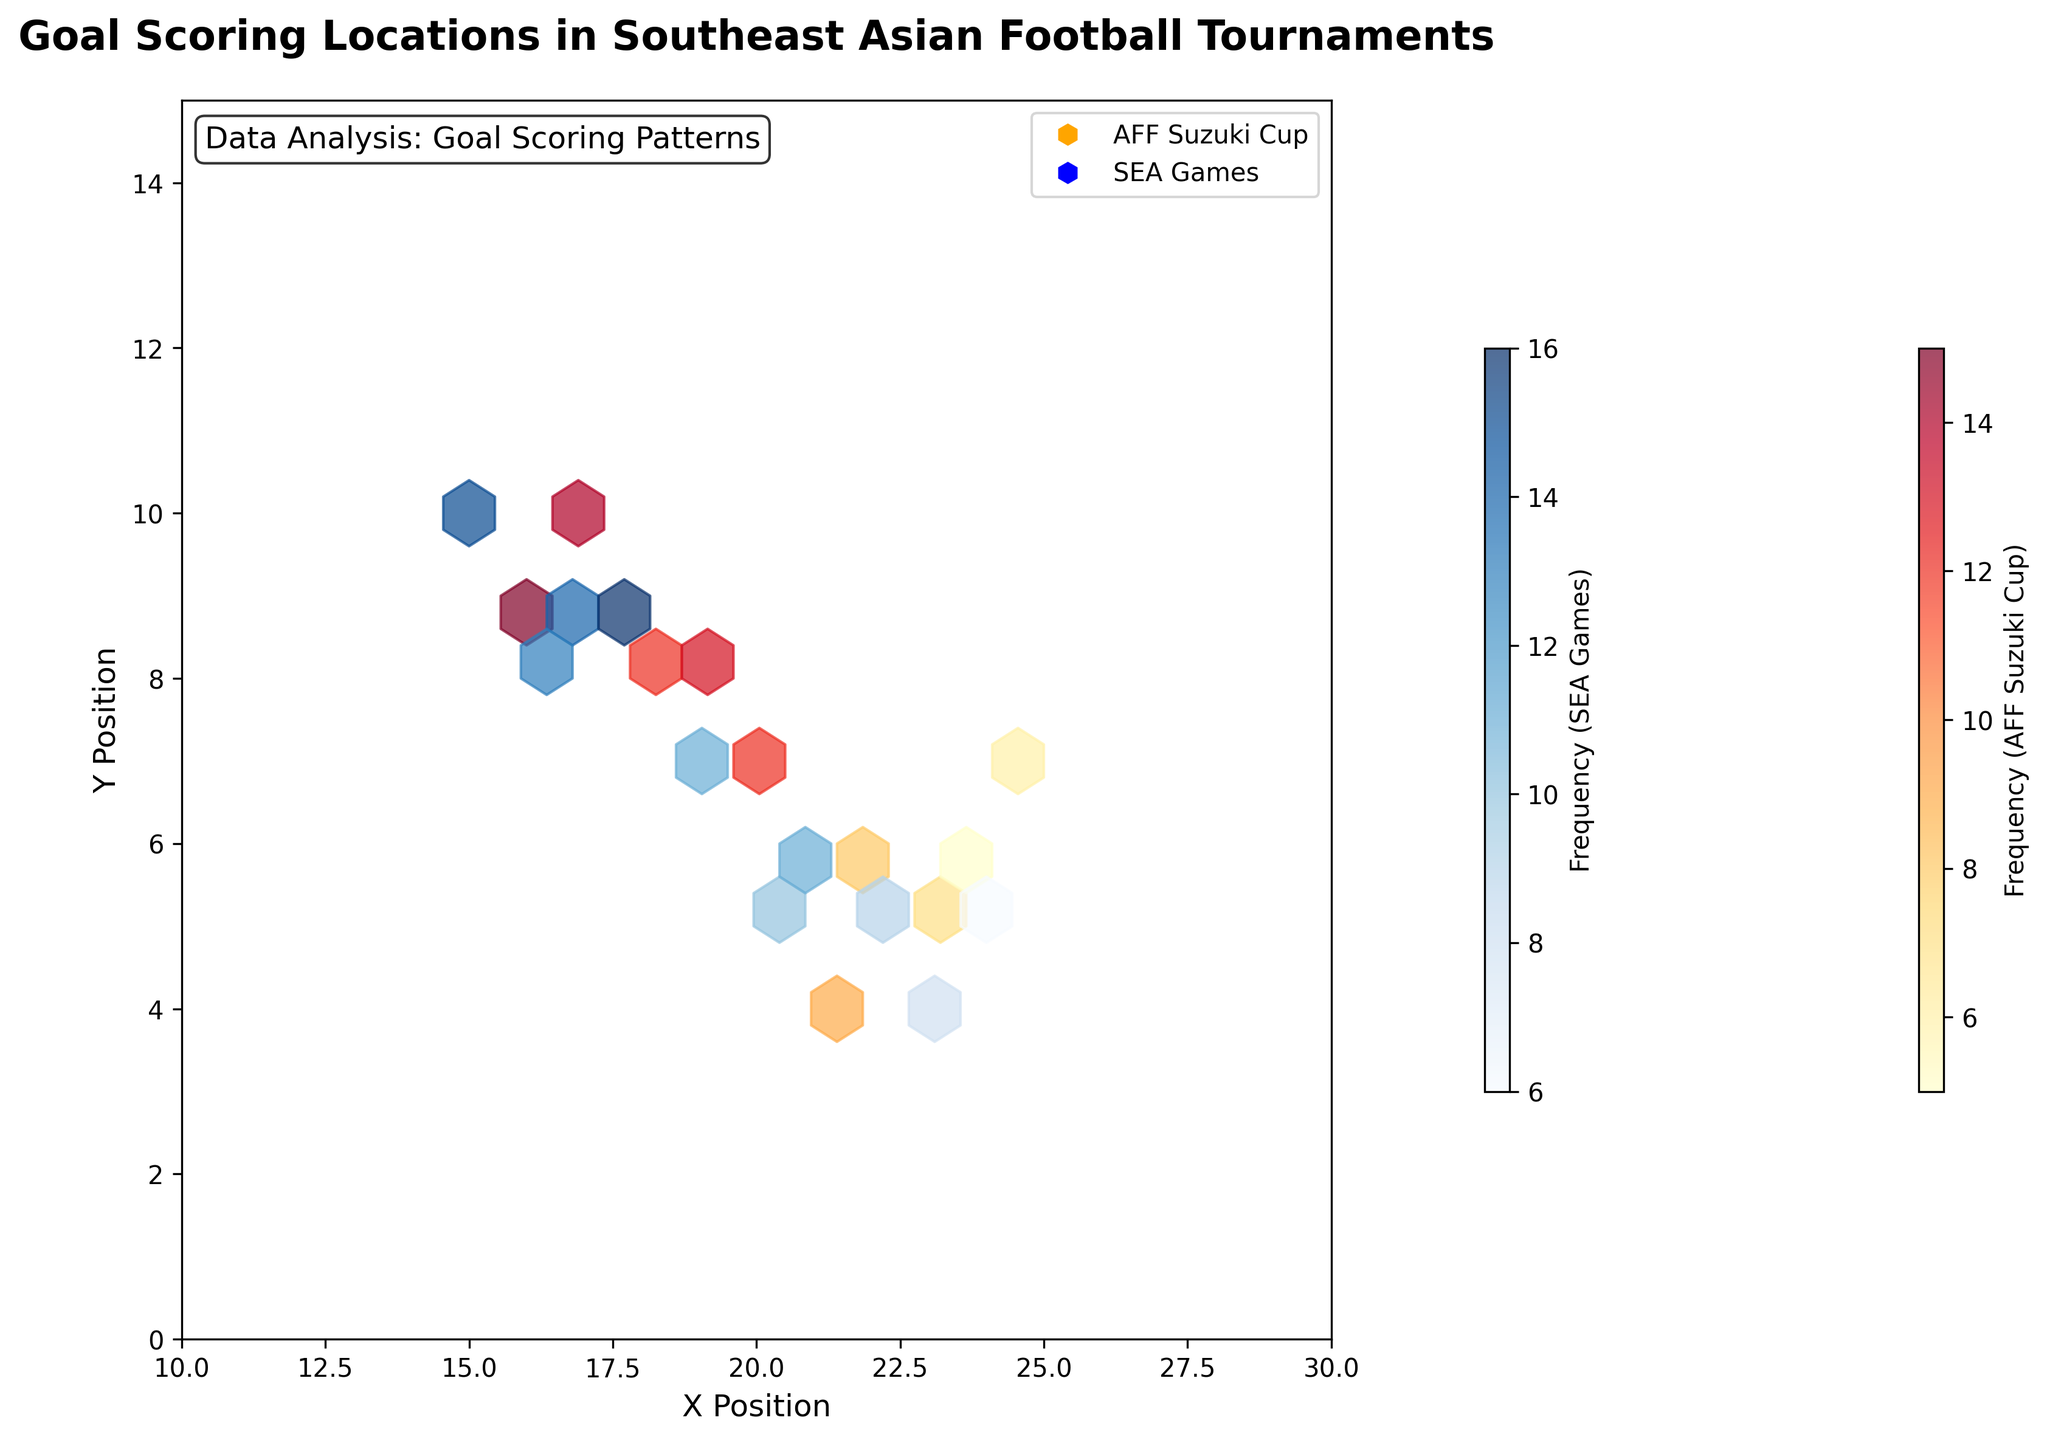Which tournament has the highest goal scoring frequency at x=18, y=8? The hexbin plot will show different color intensities for different frequencies. You'll identify the tournament with the highest frequency by comparing the colors at the specified location. Assuming 'YlOrRd' for AFF Suzuki Cup and 'Blues' for SEA Games, you compare both. In this case, AFF Suzuki Cup has a frequency of 12, which is greater than the SEA Games data for the other points.
Answer: AFF Suzuki Cup Where is the most frequent goal scoring location in the SEA Games? The hexbin plot for SEA Games will use a 'Blues' color map to represent frequencies. Locate the point with the deepest blue color. Looking at the data, the highest frequency in SEA Games is 16, occurring at x=18, y=9.
Answer: x=18, y=9 What is the average goal frequency for the AFF Suzuki Cup? Interpolating the AFF Suzuki Cup frequencies from the data: 12, 8, 6, 9, 13, 11, 16, 6. Summing these values and dividing by the number of entries gives the average: (12+8+6+9+13+11+16+6)/8 = 10.125
Answer: 10.125 Compare the highest frequency in AFF Suzuki Cup and SEA Games. Which one is higher? The highest frequencies are indicated by the most saturated colors. For AFF Suzuki Cup, the top frequency is 16. For SEA Games, also locate the highest value in 'Blues' which is 16 as well. Therefore, there is no difference.
Answer: Equal What color mapping is used for SEA Games in the hexbin plot? In the plot, SEA Games use a 'Blues' color map to represent frequencies visually. Identify the shades on the hexbin plot, with deeper shades indicating higher frequencies.
Answer: Blues Which x and y coordinate has exactly 15 goals in the SEA Games? By checking the color intensity corresponding to 15 in the SEA Games, it occurs at x=15, y=10 as indicated by the exact frequency provided in the data.
Answer: x=15, y=10 Do different color maps help in distinguishing the tournaments on the hexbin plot? Yes, 'YlOrRd' for AFF Suzuki Cup and 'Blues' for SEA Games help visually differentiate goal frequencies in each tournament by using distinct color schemes.
Answer: Yes What are the axes labels of the hexbin plot? The x-axis is labeled 'X Position' and the y-axis is labeled 'Y Position'. You can locate these labels along the respective axes of the plot.
Answer: X Position, Y Position What is the grid size for the hexbin plots? Review the plot appearance; the hexbin's code states a grid size of 10, which defines the width and height of each hexagon bin.
Answer: 10 What is the total number of goals scored in SEA Games present in the data? Sum frequencies of all SEA Games data: 15 + 10 + 14 + 11 + 13 + 16 + 9 + 6 = 94.
Answer: 94 